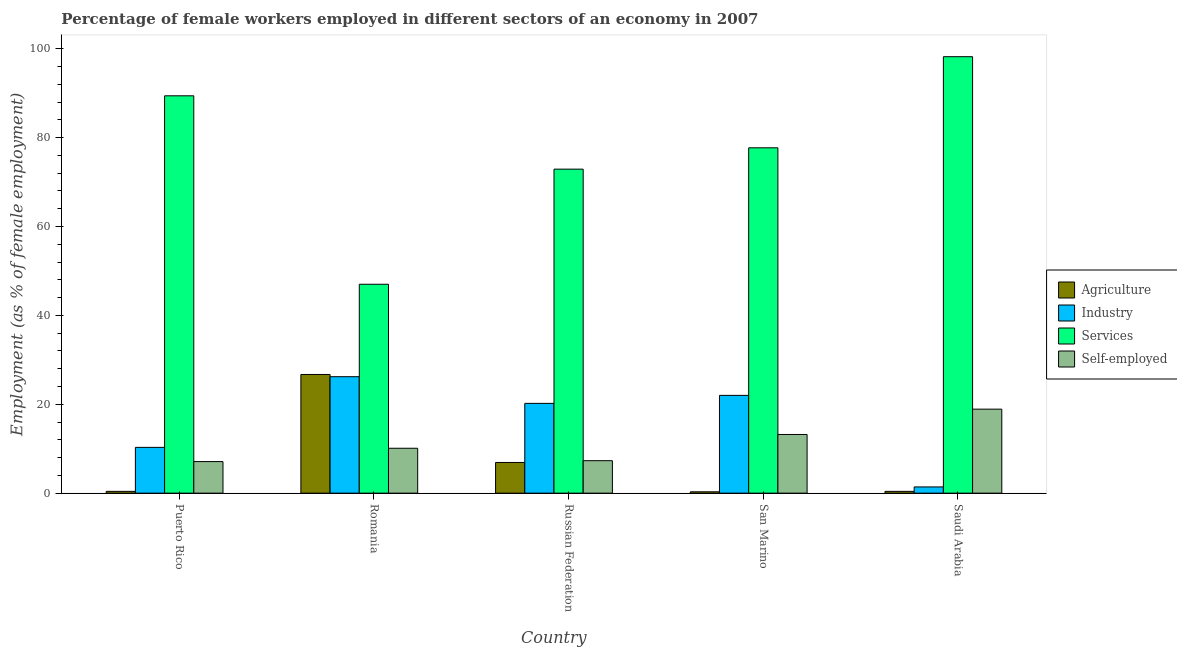How many groups of bars are there?
Offer a very short reply. 5. Are the number of bars on each tick of the X-axis equal?
Offer a terse response. Yes. How many bars are there on the 1st tick from the left?
Make the answer very short. 4. How many bars are there on the 1st tick from the right?
Provide a succinct answer. 4. What is the label of the 5th group of bars from the left?
Your answer should be very brief. Saudi Arabia. What is the percentage of female workers in services in Romania?
Your answer should be compact. 47. Across all countries, what is the maximum percentage of self employed female workers?
Offer a very short reply. 18.9. In which country was the percentage of female workers in industry maximum?
Offer a terse response. Romania. In which country was the percentage of female workers in agriculture minimum?
Make the answer very short. San Marino. What is the total percentage of self employed female workers in the graph?
Make the answer very short. 56.6. What is the difference between the percentage of self employed female workers in Romania and that in Russian Federation?
Ensure brevity in your answer.  2.8. What is the difference between the percentage of self employed female workers in Puerto Rico and the percentage of female workers in services in Russian Federation?
Provide a short and direct response. -65.8. What is the average percentage of female workers in agriculture per country?
Offer a very short reply. 6.94. What is the difference between the percentage of female workers in agriculture and percentage of self employed female workers in Russian Federation?
Ensure brevity in your answer.  -0.4. What is the ratio of the percentage of female workers in industry in Russian Federation to that in San Marino?
Keep it short and to the point. 0.92. Is the percentage of female workers in industry in Romania less than that in San Marino?
Ensure brevity in your answer.  No. What is the difference between the highest and the second highest percentage of female workers in industry?
Keep it short and to the point. 4.2. What is the difference between the highest and the lowest percentage of female workers in agriculture?
Provide a succinct answer. 26.4. Is the sum of the percentage of female workers in industry in Romania and San Marino greater than the maximum percentage of female workers in services across all countries?
Provide a short and direct response. No. Is it the case that in every country, the sum of the percentage of female workers in industry and percentage of female workers in agriculture is greater than the sum of percentage of self employed female workers and percentage of female workers in services?
Your response must be concise. No. What does the 1st bar from the left in Romania represents?
Keep it short and to the point. Agriculture. What does the 2nd bar from the right in Romania represents?
Ensure brevity in your answer.  Services. Is it the case that in every country, the sum of the percentage of female workers in agriculture and percentage of female workers in industry is greater than the percentage of female workers in services?
Offer a very short reply. No. What is the difference between two consecutive major ticks on the Y-axis?
Your answer should be very brief. 20. How many legend labels are there?
Ensure brevity in your answer.  4. How are the legend labels stacked?
Give a very brief answer. Vertical. What is the title of the graph?
Your response must be concise. Percentage of female workers employed in different sectors of an economy in 2007. Does "Business regulatory environment" appear as one of the legend labels in the graph?
Provide a succinct answer. No. What is the label or title of the X-axis?
Your answer should be very brief. Country. What is the label or title of the Y-axis?
Provide a short and direct response. Employment (as % of female employment). What is the Employment (as % of female employment) in Agriculture in Puerto Rico?
Provide a short and direct response. 0.4. What is the Employment (as % of female employment) of Industry in Puerto Rico?
Offer a very short reply. 10.3. What is the Employment (as % of female employment) in Services in Puerto Rico?
Give a very brief answer. 89.4. What is the Employment (as % of female employment) of Self-employed in Puerto Rico?
Make the answer very short. 7.1. What is the Employment (as % of female employment) in Agriculture in Romania?
Offer a very short reply. 26.7. What is the Employment (as % of female employment) of Industry in Romania?
Your answer should be very brief. 26.2. What is the Employment (as % of female employment) in Services in Romania?
Provide a succinct answer. 47. What is the Employment (as % of female employment) of Self-employed in Romania?
Your response must be concise. 10.1. What is the Employment (as % of female employment) in Agriculture in Russian Federation?
Your answer should be very brief. 6.9. What is the Employment (as % of female employment) of Industry in Russian Federation?
Ensure brevity in your answer.  20.2. What is the Employment (as % of female employment) in Services in Russian Federation?
Your answer should be very brief. 72.9. What is the Employment (as % of female employment) in Self-employed in Russian Federation?
Your answer should be very brief. 7.3. What is the Employment (as % of female employment) in Agriculture in San Marino?
Provide a short and direct response. 0.3. What is the Employment (as % of female employment) in Industry in San Marino?
Offer a terse response. 22. What is the Employment (as % of female employment) in Services in San Marino?
Offer a very short reply. 77.7. What is the Employment (as % of female employment) of Self-employed in San Marino?
Give a very brief answer. 13.2. What is the Employment (as % of female employment) in Agriculture in Saudi Arabia?
Offer a very short reply. 0.4. What is the Employment (as % of female employment) in Industry in Saudi Arabia?
Provide a short and direct response. 1.4. What is the Employment (as % of female employment) of Services in Saudi Arabia?
Keep it short and to the point. 98.2. What is the Employment (as % of female employment) in Self-employed in Saudi Arabia?
Your answer should be compact. 18.9. Across all countries, what is the maximum Employment (as % of female employment) in Agriculture?
Give a very brief answer. 26.7. Across all countries, what is the maximum Employment (as % of female employment) of Industry?
Make the answer very short. 26.2. Across all countries, what is the maximum Employment (as % of female employment) in Services?
Keep it short and to the point. 98.2. Across all countries, what is the maximum Employment (as % of female employment) of Self-employed?
Offer a very short reply. 18.9. Across all countries, what is the minimum Employment (as % of female employment) of Agriculture?
Keep it short and to the point. 0.3. Across all countries, what is the minimum Employment (as % of female employment) of Industry?
Give a very brief answer. 1.4. Across all countries, what is the minimum Employment (as % of female employment) in Self-employed?
Your response must be concise. 7.1. What is the total Employment (as % of female employment) of Agriculture in the graph?
Ensure brevity in your answer.  34.7. What is the total Employment (as % of female employment) of Industry in the graph?
Ensure brevity in your answer.  80.1. What is the total Employment (as % of female employment) in Services in the graph?
Your response must be concise. 385.2. What is the total Employment (as % of female employment) in Self-employed in the graph?
Your answer should be very brief. 56.6. What is the difference between the Employment (as % of female employment) of Agriculture in Puerto Rico and that in Romania?
Ensure brevity in your answer.  -26.3. What is the difference between the Employment (as % of female employment) of Industry in Puerto Rico and that in Romania?
Your answer should be compact. -15.9. What is the difference between the Employment (as % of female employment) in Services in Puerto Rico and that in Romania?
Your answer should be compact. 42.4. What is the difference between the Employment (as % of female employment) in Agriculture in Puerto Rico and that in Russian Federation?
Give a very brief answer. -6.5. What is the difference between the Employment (as % of female employment) of Services in Puerto Rico and that in Russian Federation?
Provide a succinct answer. 16.5. What is the difference between the Employment (as % of female employment) in Agriculture in Puerto Rico and that in Saudi Arabia?
Provide a succinct answer. 0. What is the difference between the Employment (as % of female employment) of Services in Puerto Rico and that in Saudi Arabia?
Your answer should be compact. -8.8. What is the difference between the Employment (as % of female employment) of Self-employed in Puerto Rico and that in Saudi Arabia?
Keep it short and to the point. -11.8. What is the difference between the Employment (as % of female employment) of Agriculture in Romania and that in Russian Federation?
Give a very brief answer. 19.8. What is the difference between the Employment (as % of female employment) in Services in Romania and that in Russian Federation?
Offer a very short reply. -25.9. What is the difference between the Employment (as % of female employment) in Self-employed in Romania and that in Russian Federation?
Your answer should be very brief. 2.8. What is the difference between the Employment (as % of female employment) in Agriculture in Romania and that in San Marino?
Provide a short and direct response. 26.4. What is the difference between the Employment (as % of female employment) of Services in Romania and that in San Marino?
Offer a terse response. -30.7. What is the difference between the Employment (as % of female employment) of Self-employed in Romania and that in San Marino?
Provide a short and direct response. -3.1. What is the difference between the Employment (as % of female employment) in Agriculture in Romania and that in Saudi Arabia?
Provide a succinct answer. 26.3. What is the difference between the Employment (as % of female employment) of Industry in Romania and that in Saudi Arabia?
Your answer should be compact. 24.8. What is the difference between the Employment (as % of female employment) in Services in Romania and that in Saudi Arabia?
Provide a short and direct response. -51.2. What is the difference between the Employment (as % of female employment) of Self-employed in Romania and that in Saudi Arabia?
Your answer should be compact. -8.8. What is the difference between the Employment (as % of female employment) of Services in Russian Federation and that in San Marino?
Offer a very short reply. -4.8. What is the difference between the Employment (as % of female employment) of Agriculture in Russian Federation and that in Saudi Arabia?
Provide a succinct answer. 6.5. What is the difference between the Employment (as % of female employment) of Industry in Russian Federation and that in Saudi Arabia?
Provide a short and direct response. 18.8. What is the difference between the Employment (as % of female employment) of Services in Russian Federation and that in Saudi Arabia?
Offer a terse response. -25.3. What is the difference between the Employment (as % of female employment) of Self-employed in Russian Federation and that in Saudi Arabia?
Provide a short and direct response. -11.6. What is the difference between the Employment (as % of female employment) in Agriculture in San Marino and that in Saudi Arabia?
Provide a short and direct response. -0.1. What is the difference between the Employment (as % of female employment) of Industry in San Marino and that in Saudi Arabia?
Your response must be concise. 20.6. What is the difference between the Employment (as % of female employment) of Services in San Marino and that in Saudi Arabia?
Give a very brief answer. -20.5. What is the difference between the Employment (as % of female employment) in Self-employed in San Marino and that in Saudi Arabia?
Offer a very short reply. -5.7. What is the difference between the Employment (as % of female employment) of Agriculture in Puerto Rico and the Employment (as % of female employment) of Industry in Romania?
Offer a terse response. -25.8. What is the difference between the Employment (as % of female employment) in Agriculture in Puerto Rico and the Employment (as % of female employment) in Services in Romania?
Provide a succinct answer. -46.6. What is the difference between the Employment (as % of female employment) of Industry in Puerto Rico and the Employment (as % of female employment) of Services in Romania?
Make the answer very short. -36.7. What is the difference between the Employment (as % of female employment) of Industry in Puerto Rico and the Employment (as % of female employment) of Self-employed in Romania?
Keep it short and to the point. 0.2. What is the difference between the Employment (as % of female employment) in Services in Puerto Rico and the Employment (as % of female employment) in Self-employed in Romania?
Provide a short and direct response. 79.3. What is the difference between the Employment (as % of female employment) of Agriculture in Puerto Rico and the Employment (as % of female employment) of Industry in Russian Federation?
Your answer should be very brief. -19.8. What is the difference between the Employment (as % of female employment) of Agriculture in Puerto Rico and the Employment (as % of female employment) of Services in Russian Federation?
Provide a succinct answer. -72.5. What is the difference between the Employment (as % of female employment) in Industry in Puerto Rico and the Employment (as % of female employment) in Services in Russian Federation?
Ensure brevity in your answer.  -62.6. What is the difference between the Employment (as % of female employment) in Services in Puerto Rico and the Employment (as % of female employment) in Self-employed in Russian Federation?
Your answer should be compact. 82.1. What is the difference between the Employment (as % of female employment) in Agriculture in Puerto Rico and the Employment (as % of female employment) in Industry in San Marino?
Give a very brief answer. -21.6. What is the difference between the Employment (as % of female employment) of Agriculture in Puerto Rico and the Employment (as % of female employment) of Services in San Marino?
Your response must be concise. -77.3. What is the difference between the Employment (as % of female employment) of Agriculture in Puerto Rico and the Employment (as % of female employment) of Self-employed in San Marino?
Offer a very short reply. -12.8. What is the difference between the Employment (as % of female employment) in Industry in Puerto Rico and the Employment (as % of female employment) in Services in San Marino?
Your answer should be compact. -67.4. What is the difference between the Employment (as % of female employment) in Industry in Puerto Rico and the Employment (as % of female employment) in Self-employed in San Marino?
Offer a terse response. -2.9. What is the difference between the Employment (as % of female employment) in Services in Puerto Rico and the Employment (as % of female employment) in Self-employed in San Marino?
Your answer should be very brief. 76.2. What is the difference between the Employment (as % of female employment) in Agriculture in Puerto Rico and the Employment (as % of female employment) in Services in Saudi Arabia?
Keep it short and to the point. -97.8. What is the difference between the Employment (as % of female employment) of Agriculture in Puerto Rico and the Employment (as % of female employment) of Self-employed in Saudi Arabia?
Provide a succinct answer. -18.5. What is the difference between the Employment (as % of female employment) of Industry in Puerto Rico and the Employment (as % of female employment) of Services in Saudi Arabia?
Make the answer very short. -87.9. What is the difference between the Employment (as % of female employment) of Industry in Puerto Rico and the Employment (as % of female employment) of Self-employed in Saudi Arabia?
Provide a succinct answer. -8.6. What is the difference between the Employment (as % of female employment) of Services in Puerto Rico and the Employment (as % of female employment) of Self-employed in Saudi Arabia?
Keep it short and to the point. 70.5. What is the difference between the Employment (as % of female employment) of Agriculture in Romania and the Employment (as % of female employment) of Industry in Russian Federation?
Provide a succinct answer. 6.5. What is the difference between the Employment (as % of female employment) in Agriculture in Romania and the Employment (as % of female employment) in Services in Russian Federation?
Keep it short and to the point. -46.2. What is the difference between the Employment (as % of female employment) in Agriculture in Romania and the Employment (as % of female employment) in Self-employed in Russian Federation?
Your answer should be very brief. 19.4. What is the difference between the Employment (as % of female employment) in Industry in Romania and the Employment (as % of female employment) in Services in Russian Federation?
Offer a terse response. -46.7. What is the difference between the Employment (as % of female employment) of Industry in Romania and the Employment (as % of female employment) of Self-employed in Russian Federation?
Offer a terse response. 18.9. What is the difference between the Employment (as % of female employment) in Services in Romania and the Employment (as % of female employment) in Self-employed in Russian Federation?
Your answer should be very brief. 39.7. What is the difference between the Employment (as % of female employment) of Agriculture in Romania and the Employment (as % of female employment) of Services in San Marino?
Offer a very short reply. -51. What is the difference between the Employment (as % of female employment) of Agriculture in Romania and the Employment (as % of female employment) of Self-employed in San Marino?
Provide a short and direct response. 13.5. What is the difference between the Employment (as % of female employment) of Industry in Romania and the Employment (as % of female employment) of Services in San Marino?
Your answer should be very brief. -51.5. What is the difference between the Employment (as % of female employment) in Industry in Romania and the Employment (as % of female employment) in Self-employed in San Marino?
Give a very brief answer. 13. What is the difference between the Employment (as % of female employment) of Services in Romania and the Employment (as % of female employment) of Self-employed in San Marino?
Your answer should be very brief. 33.8. What is the difference between the Employment (as % of female employment) of Agriculture in Romania and the Employment (as % of female employment) of Industry in Saudi Arabia?
Provide a short and direct response. 25.3. What is the difference between the Employment (as % of female employment) of Agriculture in Romania and the Employment (as % of female employment) of Services in Saudi Arabia?
Your answer should be very brief. -71.5. What is the difference between the Employment (as % of female employment) of Industry in Romania and the Employment (as % of female employment) of Services in Saudi Arabia?
Ensure brevity in your answer.  -72. What is the difference between the Employment (as % of female employment) of Services in Romania and the Employment (as % of female employment) of Self-employed in Saudi Arabia?
Your answer should be compact. 28.1. What is the difference between the Employment (as % of female employment) of Agriculture in Russian Federation and the Employment (as % of female employment) of Industry in San Marino?
Give a very brief answer. -15.1. What is the difference between the Employment (as % of female employment) in Agriculture in Russian Federation and the Employment (as % of female employment) in Services in San Marino?
Provide a succinct answer. -70.8. What is the difference between the Employment (as % of female employment) in Industry in Russian Federation and the Employment (as % of female employment) in Services in San Marino?
Make the answer very short. -57.5. What is the difference between the Employment (as % of female employment) in Services in Russian Federation and the Employment (as % of female employment) in Self-employed in San Marino?
Make the answer very short. 59.7. What is the difference between the Employment (as % of female employment) of Agriculture in Russian Federation and the Employment (as % of female employment) of Services in Saudi Arabia?
Offer a very short reply. -91.3. What is the difference between the Employment (as % of female employment) in Industry in Russian Federation and the Employment (as % of female employment) in Services in Saudi Arabia?
Provide a succinct answer. -78. What is the difference between the Employment (as % of female employment) of Industry in Russian Federation and the Employment (as % of female employment) of Self-employed in Saudi Arabia?
Your response must be concise. 1.3. What is the difference between the Employment (as % of female employment) in Services in Russian Federation and the Employment (as % of female employment) in Self-employed in Saudi Arabia?
Your response must be concise. 54. What is the difference between the Employment (as % of female employment) of Agriculture in San Marino and the Employment (as % of female employment) of Services in Saudi Arabia?
Ensure brevity in your answer.  -97.9. What is the difference between the Employment (as % of female employment) of Agriculture in San Marino and the Employment (as % of female employment) of Self-employed in Saudi Arabia?
Offer a terse response. -18.6. What is the difference between the Employment (as % of female employment) of Industry in San Marino and the Employment (as % of female employment) of Services in Saudi Arabia?
Keep it short and to the point. -76.2. What is the difference between the Employment (as % of female employment) of Services in San Marino and the Employment (as % of female employment) of Self-employed in Saudi Arabia?
Make the answer very short. 58.8. What is the average Employment (as % of female employment) of Agriculture per country?
Keep it short and to the point. 6.94. What is the average Employment (as % of female employment) in Industry per country?
Provide a succinct answer. 16.02. What is the average Employment (as % of female employment) of Services per country?
Make the answer very short. 77.04. What is the average Employment (as % of female employment) in Self-employed per country?
Keep it short and to the point. 11.32. What is the difference between the Employment (as % of female employment) of Agriculture and Employment (as % of female employment) of Services in Puerto Rico?
Keep it short and to the point. -89. What is the difference between the Employment (as % of female employment) in Industry and Employment (as % of female employment) in Services in Puerto Rico?
Your answer should be very brief. -79.1. What is the difference between the Employment (as % of female employment) of Industry and Employment (as % of female employment) of Self-employed in Puerto Rico?
Ensure brevity in your answer.  3.2. What is the difference between the Employment (as % of female employment) in Services and Employment (as % of female employment) in Self-employed in Puerto Rico?
Your answer should be very brief. 82.3. What is the difference between the Employment (as % of female employment) of Agriculture and Employment (as % of female employment) of Industry in Romania?
Offer a terse response. 0.5. What is the difference between the Employment (as % of female employment) in Agriculture and Employment (as % of female employment) in Services in Romania?
Give a very brief answer. -20.3. What is the difference between the Employment (as % of female employment) in Agriculture and Employment (as % of female employment) in Self-employed in Romania?
Ensure brevity in your answer.  16.6. What is the difference between the Employment (as % of female employment) in Industry and Employment (as % of female employment) in Services in Romania?
Make the answer very short. -20.8. What is the difference between the Employment (as % of female employment) of Services and Employment (as % of female employment) of Self-employed in Romania?
Provide a succinct answer. 36.9. What is the difference between the Employment (as % of female employment) of Agriculture and Employment (as % of female employment) of Services in Russian Federation?
Give a very brief answer. -66. What is the difference between the Employment (as % of female employment) of Agriculture and Employment (as % of female employment) of Self-employed in Russian Federation?
Your response must be concise. -0.4. What is the difference between the Employment (as % of female employment) of Industry and Employment (as % of female employment) of Services in Russian Federation?
Offer a terse response. -52.7. What is the difference between the Employment (as % of female employment) in Industry and Employment (as % of female employment) in Self-employed in Russian Federation?
Your answer should be compact. 12.9. What is the difference between the Employment (as % of female employment) in Services and Employment (as % of female employment) in Self-employed in Russian Federation?
Provide a short and direct response. 65.6. What is the difference between the Employment (as % of female employment) of Agriculture and Employment (as % of female employment) of Industry in San Marino?
Your response must be concise. -21.7. What is the difference between the Employment (as % of female employment) in Agriculture and Employment (as % of female employment) in Services in San Marino?
Provide a short and direct response. -77.4. What is the difference between the Employment (as % of female employment) of Industry and Employment (as % of female employment) of Services in San Marino?
Offer a terse response. -55.7. What is the difference between the Employment (as % of female employment) in Industry and Employment (as % of female employment) in Self-employed in San Marino?
Your answer should be very brief. 8.8. What is the difference between the Employment (as % of female employment) in Services and Employment (as % of female employment) in Self-employed in San Marino?
Give a very brief answer. 64.5. What is the difference between the Employment (as % of female employment) of Agriculture and Employment (as % of female employment) of Services in Saudi Arabia?
Offer a very short reply. -97.8. What is the difference between the Employment (as % of female employment) in Agriculture and Employment (as % of female employment) in Self-employed in Saudi Arabia?
Provide a succinct answer. -18.5. What is the difference between the Employment (as % of female employment) in Industry and Employment (as % of female employment) in Services in Saudi Arabia?
Your answer should be very brief. -96.8. What is the difference between the Employment (as % of female employment) in Industry and Employment (as % of female employment) in Self-employed in Saudi Arabia?
Offer a very short reply. -17.5. What is the difference between the Employment (as % of female employment) of Services and Employment (as % of female employment) of Self-employed in Saudi Arabia?
Your answer should be very brief. 79.3. What is the ratio of the Employment (as % of female employment) of Agriculture in Puerto Rico to that in Romania?
Give a very brief answer. 0.01. What is the ratio of the Employment (as % of female employment) of Industry in Puerto Rico to that in Romania?
Your answer should be very brief. 0.39. What is the ratio of the Employment (as % of female employment) of Services in Puerto Rico to that in Romania?
Offer a terse response. 1.9. What is the ratio of the Employment (as % of female employment) in Self-employed in Puerto Rico to that in Romania?
Your answer should be compact. 0.7. What is the ratio of the Employment (as % of female employment) of Agriculture in Puerto Rico to that in Russian Federation?
Provide a short and direct response. 0.06. What is the ratio of the Employment (as % of female employment) in Industry in Puerto Rico to that in Russian Federation?
Give a very brief answer. 0.51. What is the ratio of the Employment (as % of female employment) in Services in Puerto Rico to that in Russian Federation?
Ensure brevity in your answer.  1.23. What is the ratio of the Employment (as % of female employment) in Self-employed in Puerto Rico to that in Russian Federation?
Offer a very short reply. 0.97. What is the ratio of the Employment (as % of female employment) in Industry in Puerto Rico to that in San Marino?
Provide a short and direct response. 0.47. What is the ratio of the Employment (as % of female employment) in Services in Puerto Rico to that in San Marino?
Give a very brief answer. 1.15. What is the ratio of the Employment (as % of female employment) in Self-employed in Puerto Rico to that in San Marino?
Offer a terse response. 0.54. What is the ratio of the Employment (as % of female employment) of Agriculture in Puerto Rico to that in Saudi Arabia?
Provide a short and direct response. 1. What is the ratio of the Employment (as % of female employment) in Industry in Puerto Rico to that in Saudi Arabia?
Provide a short and direct response. 7.36. What is the ratio of the Employment (as % of female employment) of Services in Puerto Rico to that in Saudi Arabia?
Your response must be concise. 0.91. What is the ratio of the Employment (as % of female employment) of Self-employed in Puerto Rico to that in Saudi Arabia?
Provide a succinct answer. 0.38. What is the ratio of the Employment (as % of female employment) of Agriculture in Romania to that in Russian Federation?
Make the answer very short. 3.87. What is the ratio of the Employment (as % of female employment) in Industry in Romania to that in Russian Federation?
Provide a short and direct response. 1.3. What is the ratio of the Employment (as % of female employment) in Services in Romania to that in Russian Federation?
Provide a succinct answer. 0.64. What is the ratio of the Employment (as % of female employment) in Self-employed in Romania to that in Russian Federation?
Give a very brief answer. 1.38. What is the ratio of the Employment (as % of female employment) of Agriculture in Romania to that in San Marino?
Your response must be concise. 89. What is the ratio of the Employment (as % of female employment) of Industry in Romania to that in San Marino?
Your answer should be very brief. 1.19. What is the ratio of the Employment (as % of female employment) of Services in Romania to that in San Marino?
Provide a short and direct response. 0.6. What is the ratio of the Employment (as % of female employment) in Self-employed in Romania to that in San Marino?
Your answer should be very brief. 0.77. What is the ratio of the Employment (as % of female employment) in Agriculture in Romania to that in Saudi Arabia?
Your response must be concise. 66.75. What is the ratio of the Employment (as % of female employment) of Industry in Romania to that in Saudi Arabia?
Your answer should be compact. 18.71. What is the ratio of the Employment (as % of female employment) in Services in Romania to that in Saudi Arabia?
Your response must be concise. 0.48. What is the ratio of the Employment (as % of female employment) in Self-employed in Romania to that in Saudi Arabia?
Offer a terse response. 0.53. What is the ratio of the Employment (as % of female employment) of Industry in Russian Federation to that in San Marino?
Keep it short and to the point. 0.92. What is the ratio of the Employment (as % of female employment) in Services in Russian Federation to that in San Marino?
Your answer should be very brief. 0.94. What is the ratio of the Employment (as % of female employment) in Self-employed in Russian Federation to that in San Marino?
Make the answer very short. 0.55. What is the ratio of the Employment (as % of female employment) in Agriculture in Russian Federation to that in Saudi Arabia?
Make the answer very short. 17.25. What is the ratio of the Employment (as % of female employment) in Industry in Russian Federation to that in Saudi Arabia?
Offer a very short reply. 14.43. What is the ratio of the Employment (as % of female employment) in Services in Russian Federation to that in Saudi Arabia?
Give a very brief answer. 0.74. What is the ratio of the Employment (as % of female employment) in Self-employed in Russian Federation to that in Saudi Arabia?
Offer a terse response. 0.39. What is the ratio of the Employment (as % of female employment) in Agriculture in San Marino to that in Saudi Arabia?
Provide a short and direct response. 0.75. What is the ratio of the Employment (as % of female employment) in Industry in San Marino to that in Saudi Arabia?
Your response must be concise. 15.71. What is the ratio of the Employment (as % of female employment) of Services in San Marino to that in Saudi Arabia?
Your response must be concise. 0.79. What is the ratio of the Employment (as % of female employment) in Self-employed in San Marino to that in Saudi Arabia?
Your answer should be very brief. 0.7. What is the difference between the highest and the second highest Employment (as % of female employment) of Agriculture?
Keep it short and to the point. 19.8. What is the difference between the highest and the second highest Employment (as % of female employment) in Industry?
Keep it short and to the point. 4.2. What is the difference between the highest and the second highest Employment (as % of female employment) of Services?
Offer a terse response. 8.8. What is the difference between the highest and the lowest Employment (as % of female employment) of Agriculture?
Keep it short and to the point. 26.4. What is the difference between the highest and the lowest Employment (as % of female employment) in Industry?
Your answer should be very brief. 24.8. What is the difference between the highest and the lowest Employment (as % of female employment) of Services?
Give a very brief answer. 51.2. 